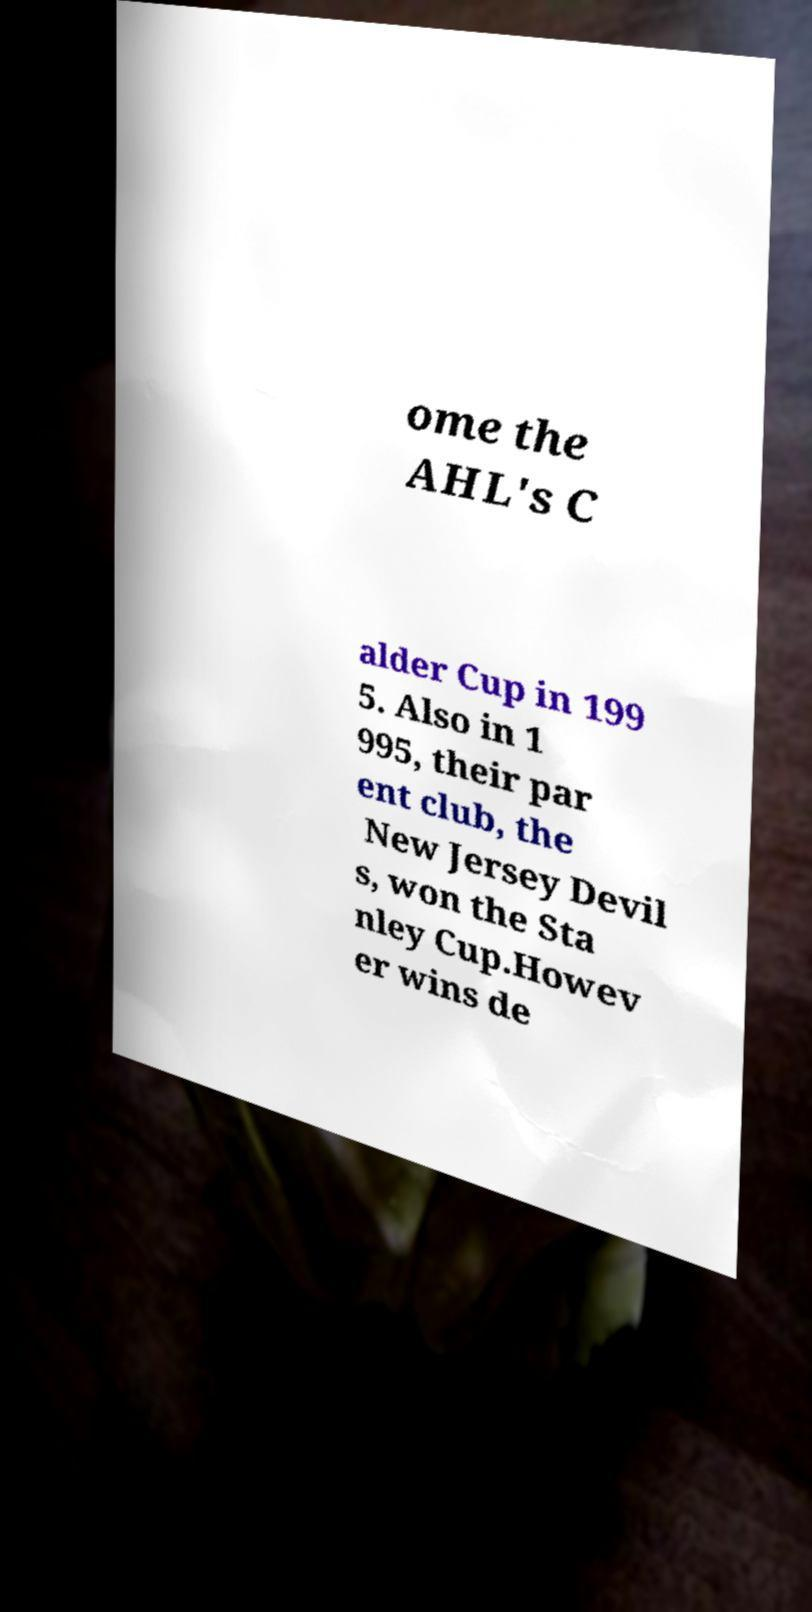Can you read and provide the text displayed in the image?This photo seems to have some interesting text. Can you extract and type it out for me? ome the AHL's C alder Cup in 199 5. Also in 1 995, their par ent club, the New Jersey Devil s, won the Sta nley Cup.Howev er wins de 